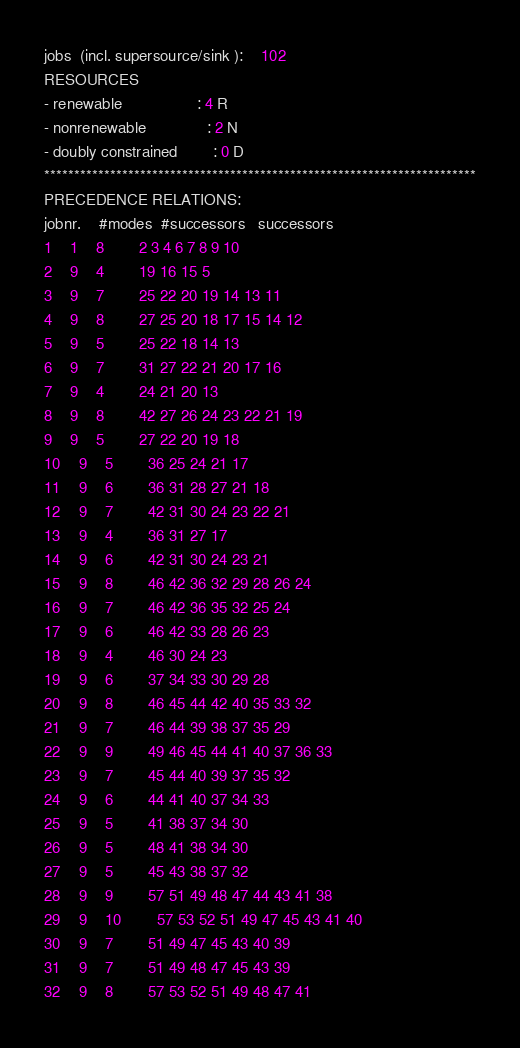Convert code to text. <code><loc_0><loc_0><loc_500><loc_500><_ObjectiveC_>jobs  (incl. supersource/sink ):	102
RESOURCES
- renewable                 : 4 R
- nonrenewable              : 2 N
- doubly constrained        : 0 D
************************************************************************
PRECEDENCE RELATIONS:
jobnr.    #modes  #successors   successors
1	1	8		2 3 4 6 7 8 9 10 
2	9	4		19 16 15 5 
3	9	7		25 22 20 19 14 13 11 
4	9	8		27 25 20 18 17 15 14 12 
5	9	5		25 22 18 14 13 
6	9	7		31 27 22 21 20 17 16 
7	9	4		24 21 20 13 
8	9	8		42 27 26 24 23 22 21 19 
9	9	5		27 22 20 19 18 
10	9	5		36 25 24 21 17 
11	9	6		36 31 28 27 21 18 
12	9	7		42 31 30 24 23 22 21 
13	9	4		36 31 27 17 
14	9	6		42 31 30 24 23 21 
15	9	8		46 42 36 32 29 28 26 24 
16	9	7		46 42 36 35 32 25 24 
17	9	6		46 42 33 28 26 23 
18	9	4		46 30 24 23 
19	9	6		37 34 33 30 29 28 
20	9	8		46 45 44 42 40 35 33 32 
21	9	7		46 44 39 38 37 35 29 
22	9	9		49 46 45 44 41 40 37 36 33 
23	9	7		45 44 40 39 37 35 32 
24	9	6		44 41 40 37 34 33 
25	9	5		41 38 37 34 30 
26	9	5		48 41 38 34 30 
27	9	5		45 43 38 37 32 
28	9	9		57 51 49 48 47 44 43 41 38 
29	9	10		57 53 52 51 49 47 45 43 41 40 
30	9	7		51 49 47 45 43 40 39 
31	9	7		51 49 48 47 45 43 39 
32	9	8		57 53 52 51 49 48 47 41 </code> 